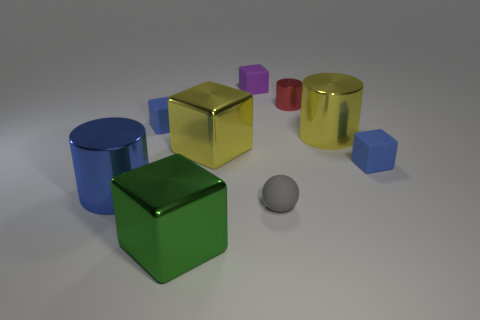Is there anything else that is the same size as the purple rubber object?
Offer a terse response. Yes. There is a yellow thing that is the same shape as the blue shiny thing; what is its size?
Provide a succinct answer. Large. Is the tiny cylinder made of the same material as the small blue cube right of the green object?
Your answer should be very brief. No. There is a object that is in front of the sphere; what is its size?
Your answer should be very brief. Large. What size is the yellow cylinder that is the same material as the red cylinder?
Offer a very short reply. Large. What number of rubber blocks have the same color as the small matte ball?
Keep it short and to the point. 0. Are any tiny red rubber cylinders visible?
Your answer should be very brief. No. Does the purple rubber object have the same shape as the big shiny object in front of the big blue metallic object?
Your answer should be compact. Yes. What is the color of the large cylinder left of the green object that is to the left of the blue cube to the right of the small red cylinder?
Make the answer very short. Blue. Are there any blue blocks right of the tiny red metal cylinder?
Provide a succinct answer. Yes. 